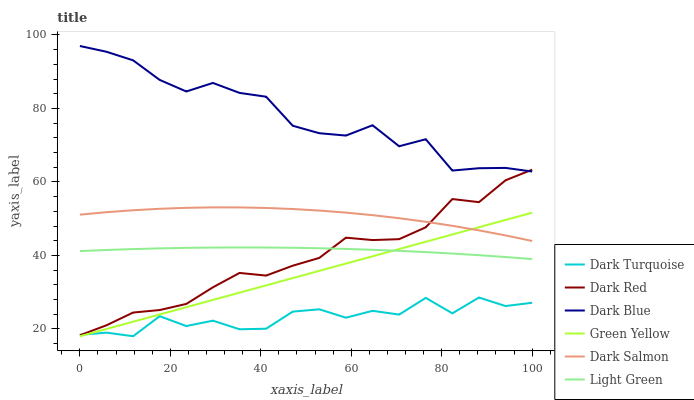Does Dark Turquoise have the minimum area under the curve?
Answer yes or no. Yes. Does Dark Blue have the maximum area under the curve?
Answer yes or no. Yes. Does Dark Salmon have the minimum area under the curve?
Answer yes or no. No. Does Dark Salmon have the maximum area under the curve?
Answer yes or no. No. Is Green Yellow the smoothest?
Answer yes or no. Yes. Is Dark Turquoise the roughest?
Answer yes or no. Yes. Is Dark Salmon the smoothest?
Answer yes or no. No. Is Dark Salmon the roughest?
Answer yes or no. No. Does Dark Turquoise have the lowest value?
Answer yes or no. Yes. Does Dark Salmon have the lowest value?
Answer yes or no. No. Does Dark Blue have the highest value?
Answer yes or no. Yes. Does Dark Salmon have the highest value?
Answer yes or no. No. Is Light Green less than Dark Salmon?
Answer yes or no. Yes. Is Dark Blue greater than Dark Turquoise?
Answer yes or no. Yes. Does Dark Turquoise intersect Green Yellow?
Answer yes or no. Yes. Is Dark Turquoise less than Green Yellow?
Answer yes or no. No. Is Dark Turquoise greater than Green Yellow?
Answer yes or no. No. Does Light Green intersect Dark Salmon?
Answer yes or no. No. 